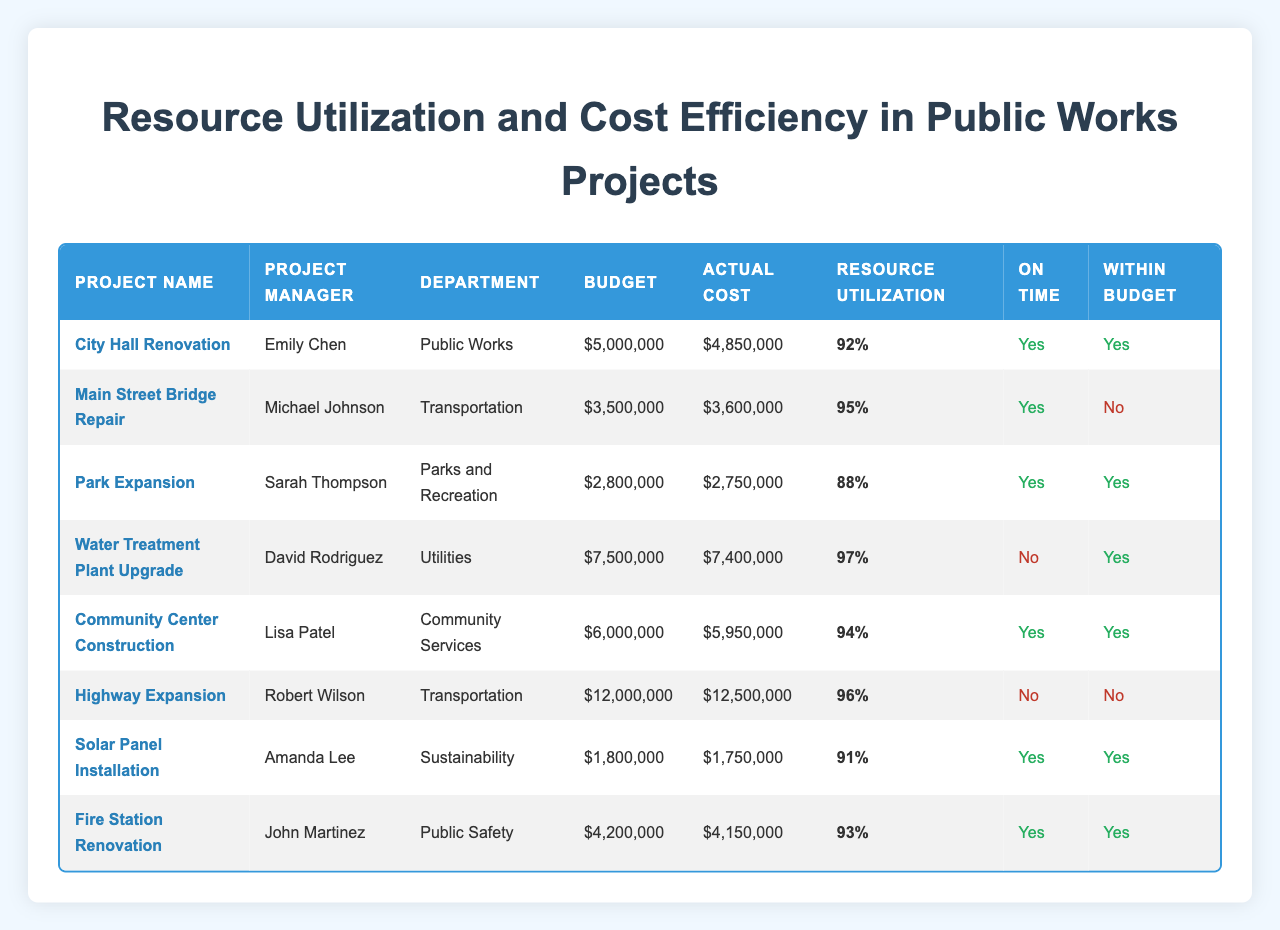What is the budget for the "Community Center Construction" project? The budget value is listed directly in the table for the "Community Center Construction" project. It shows that the budget is $6,000,000.
Answer: $6,000,000 Which project had the highest resource utilization? The resource utilization values can be compared directly in the table. The "Water Treatment Plant Upgrade" has the highest utilization at 97%.
Answer: 97% Did "Highway Expansion" stay within budget? The table indicates that "Highway Expansion" is marked under the column "Within Budget" as No, meaning it did not stay within budget.
Answer: No What is the average actual cost of all projects that were completed on time? To calculate the average, we identify the projects that are marked "On Time" in the table: City Hall Renovation, Main Street Bridge Repair, Park Expansion, Community Center Construction, Solar Panel Installation, and Fire Station Renovation. Summing their actual costs: $4,850,000 + $3,600,000 + $2,750,000 + $5,950,000 + $1,750,000 + $4,150,000 = $23,100,000. There are 6 projects, so the average actual cost is $23,100,000 / 6 = $3,850,000.
Answer: $3,850,000 Is there a project managed by Lisa Patel that was completed within budget? Referring to the table, we can see that "Community Center Construction," managed by Lisa Patel, is marked as within budget, indicating it was indeed completed financially on target.
Answer: Yes What is the total budget of all projects that were completed but not on time? First, we look for projects that are marked "Not On Time," which are: Water Treatment Plant Upgrade and Highway Expansion. Their budgets are $7,500,000 and $12,000,000 respectively. Summing these gives $7,500,000 + $12,000,000 = $19,500,000.
Answer: $19,500,000 Which project had the closest actual cost to its budget? We compare the actual costs and budgets to identify the project with the smallest difference. Calculating differences: City Hall Renovation ($5,000,000 - $4,850,000 = $150,000), Park Expansion ($2,800,000 - $2,750,000 = $50,000), and others. The smallest difference is for Park Expansion with $50,000.
Answer: Park Expansion How many projects are managed by Michael Johnson? A quick search through the table shows that Michael Johnson is the project manager for one project, "Main Street Bridge Repair". Therefore, the number of projects he manages is 1.
Answer: 1 